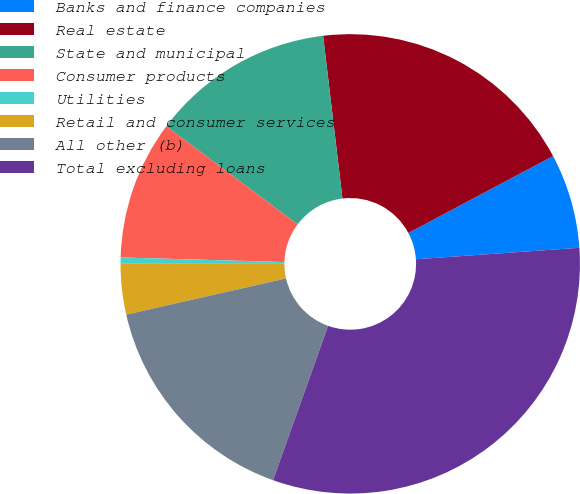Convert chart to OTSL. <chart><loc_0><loc_0><loc_500><loc_500><pie_chart><fcel>Banks and finance companies<fcel>Real estate<fcel>State and municipal<fcel>Consumer products<fcel>Utilities<fcel>Retail and consumer services<fcel>All other (b)<fcel>Total excluding loans<nl><fcel>6.66%<fcel>19.11%<fcel>12.89%<fcel>9.78%<fcel>0.44%<fcel>3.55%<fcel>16.0%<fcel>31.57%<nl></chart> 